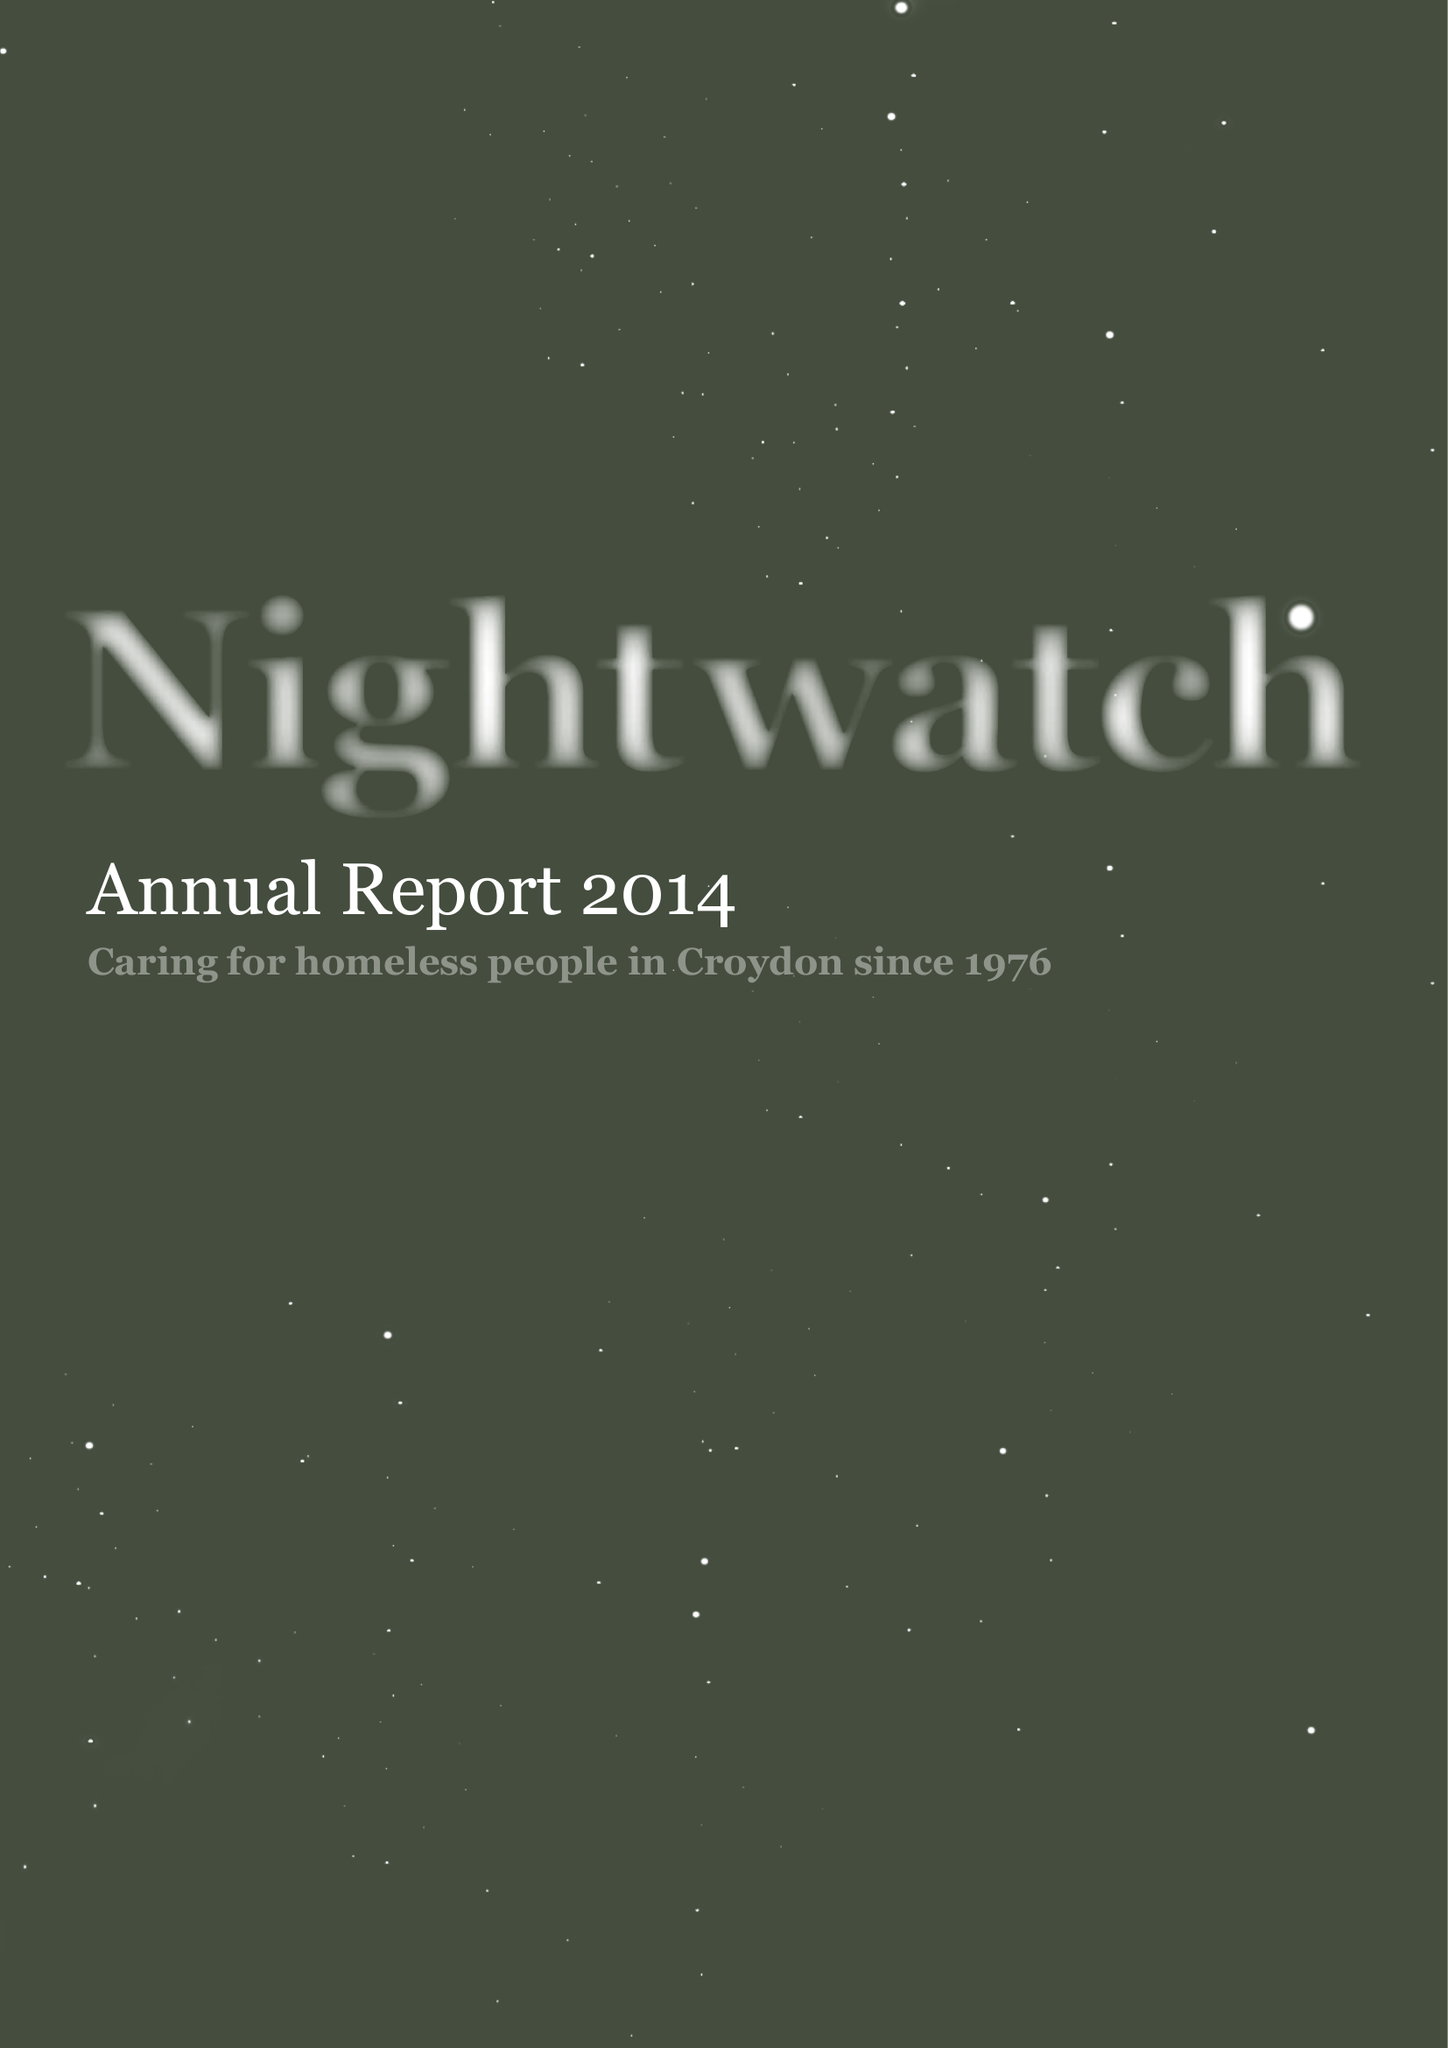What is the value for the charity_name?
Answer the question using a single word or phrase. Nightwatch 